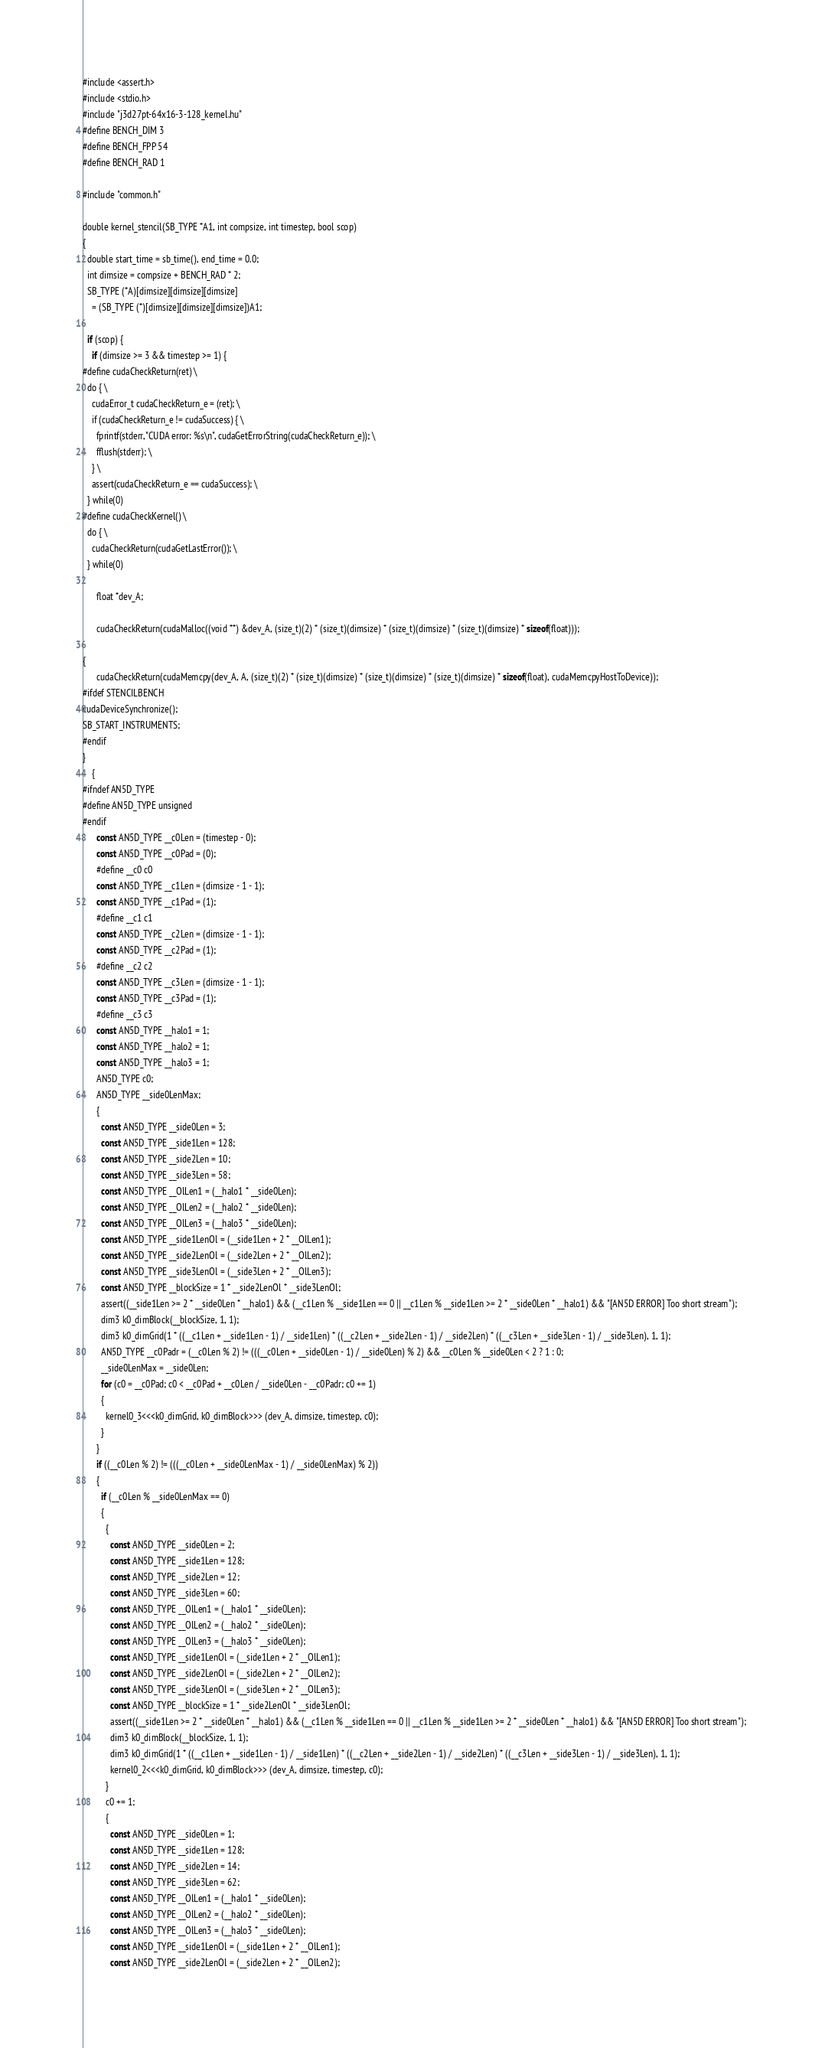<code> <loc_0><loc_0><loc_500><loc_500><_Cuda_>#include <assert.h>
#include <stdio.h>
#include "j3d27pt-64x16-3-128_kernel.hu"
#define BENCH_DIM 3
#define BENCH_FPP 54
#define BENCH_RAD 1

#include "common.h"

double kernel_stencil(SB_TYPE *A1, int compsize, int timestep, bool scop)
{
  double start_time = sb_time(), end_time = 0.0;
  int dimsize = compsize + BENCH_RAD * 2;
  SB_TYPE (*A)[dimsize][dimsize][dimsize]
    = (SB_TYPE (*)[dimsize][dimsize][dimsize])A1;

  if (scop) {
    if (dimsize >= 3 && timestep >= 1) {
#define cudaCheckReturn(ret) \
  do { \
    cudaError_t cudaCheckReturn_e = (ret); \
    if (cudaCheckReturn_e != cudaSuccess) { \
      fprintf(stderr, "CUDA error: %s\n", cudaGetErrorString(cudaCheckReturn_e)); \
      fflush(stderr); \
    } \
    assert(cudaCheckReturn_e == cudaSuccess); \
  } while(0)
#define cudaCheckKernel() \
  do { \
    cudaCheckReturn(cudaGetLastError()); \
  } while(0)

      float *dev_A;
      
      cudaCheckReturn(cudaMalloc((void **) &dev_A, (size_t)(2) * (size_t)(dimsize) * (size_t)(dimsize) * (size_t)(dimsize) * sizeof(float)));
      
{
      cudaCheckReturn(cudaMemcpy(dev_A, A, (size_t)(2) * (size_t)(dimsize) * (size_t)(dimsize) * (size_t)(dimsize) * sizeof(float), cudaMemcpyHostToDevice));
#ifdef STENCILBENCH
cudaDeviceSynchronize();
SB_START_INSTRUMENTS;
#endif
}
    {
#ifndef AN5D_TYPE
#define AN5D_TYPE unsigned
#endif
      const AN5D_TYPE __c0Len = (timestep - 0);
      const AN5D_TYPE __c0Pad = (0);
      #define __c0 c0
      const AN5D_TYPE __c1Len = (dimsize - 1 - 1);
      const AN5D_TYPE __c1Pad = (1);
      #define __c1 c1
      const AN5D_TYPE __c2Len = (dimsize - 1 - 1);
      const AN5D_TYPE __c2Pad = (1);
      #define __c2 c2
      const AN5D_TYPE __c3Len = (dimsize - 1 - 1);
      const AN5D_TYPE __c3Pad = (1);
      #define __c3 c3
      const AN5D_TYPE __halo1 = 1;
      const AN5D_TYPE __halo2 = 1;
      const AN5D_TYPE __halo3 = 1;
      AN5D_TYPE c0;
      AN5D_TYPE __side0LenMax;
      {
        const AN5D_TYPE __side0Len = 3;
        const AN5D_TYPE __side1Len = 128;
        const AN5D_TYPE __side2Len = 10;
        const AN5D_TYPE __side3Len = 58;
        const AN5D_TYPE __OlLen1 = (__halo1 * __side0Len);
        const AN5D_TYPE __OlLen2 = (__halo2 * __side0Len);
        const AN5D_TYPE __OlLen3 = (__halo3 * __side0Len);
        const AN5D_TYPE __side1LenOl = (__side1Len + 2 * __OlLen1);
        const AN5D_TYPE __side2LenOl = (__side2Len + 2 * __OlLen2);
        const AN5D_TYPE __side3LenOl = (__side3Len + 2 * __OlLen3);
        const AN5D_TYPE __blockSize = 1 * __side2LenOl * __side3LenOl;
        assert((__side1Len >= 2 * __side0Len * __halo1) && (__c1Len % __side1Len == 0 || __c1Len % __side1Len >= 2 * __side0Len * __halo1) && "[AN5D ERROR] Too short stream");
        dim3 k0_dimBlock(__blockSize, 1, 1);
        dim3 k0_dimGrid(1 * ((__c1Len + __side1Len - 1) / __side1Len) * ((__c2Len + __side2Len - 1) / __side2Len) * ((__c3Len + __side3Len - 1) / __side3Len), 1, 1);
        AN5D_TYPE __c0Padr = (__c0Len % 2) != (((__c0Len + __side0Len - 1) / __side0Len) % 2) && __c0Len % __side0Len < 2 ? 1 : 0;
        __side0LenMax = __side0Len;
        for (c0 = __c0Pad; c0 < __c0Pad + __c0Len / __side0Len - __c0Padr; c0 += 1)
        {
          kernel0_3<<<k0_dimGrid, k0_dimBlock>>> (dev_A, dimsize, timestep, c0);
        }
      }
      if ((__c0Len % 2) != (((__c0Len + __side0LenMax - 1) / __side0LenMax) % 2))
      {
        if (__c0Len % __side0LenMax == 0)
        {
          {
            const AN5D_TYPE __side0Len = 2;
            const AN5D_TYPE __side1Len = 128;
            const AN5D_TYPE __side2Len = 12;
            const AN5D_TYPE __side3Len = 60;
            const AN5D_TYPE __OlLen1 = (__halo1 * __side0Len);
            const AN5D_TYPE __OlLen2 = (__halo2 * __side0Len);
            const AN5D_TYPE __OlLen3 = (__halo3 * __side0Len);
            const AN5D_TYPE __side1LenOl = (__side1Len + 2 * __OlLen1);
            const AN5D_TYPE __side2LenOl = (__side2Len + 2 * __OlLen2);
            const AN5D_TYPE __side3LenOl = (__side3Len + 2 * __OlLen3);
            const AN5D_TYPE __blockSize = 1 * __side2LenOl * __side3LenOl;
            assert((__side1Len >= 2 * __side0Len * __halo1) && (__c1Len % __side1Len == 0 || __c1Len % __side1Len >= 2 * __side0Len * __halo1) && "[AN5D ERROR] Too short stream");
            dim3 k0_dimBlock(__blockSize, 1, 1);
            dim3 k0_dimGrid(1 * ((__c1Len + __side1Len - 1) / __side1Len) * ((__c2Len + __side2Len - 1) / __side2Len) * ((__c3Len + __side3Len - 1) / __side3Len), 1, 1);
            kernel0_2<<<k0_dimGrid, k0_dimBlock>>> (dev_A, dimsize, timestep, c0);
          }
          c0 += 1;
          {
            const AN5D_TYPE __side0Len = 1;
            const AN5D_TYPE __side1Len = 128;
            const AN5D_TYPE __side2Len = 14;
            const AN5D_TYPE __side3Len = 62;
            const AN5D_TYPE __OlLen1 = (__halo1 * __side0Len);
            const AN5D_TYPE __OlLen2 = (__halo2 * __side0Len);
            const AN5D_TYPE __OlLen3 = (__halo3 * __side0Len);
            const AN5D_TYPE __side1LenOl = (__side1Len + 2 * __OlLen1);
            const AN5D_TYPE __side2LenOl = (__side2Len + 2 * __OlLen2);</code> 